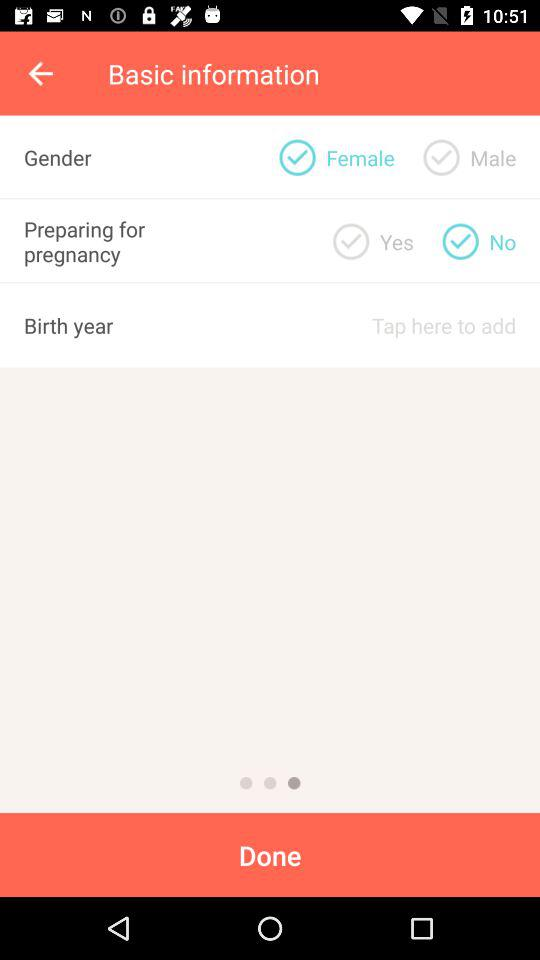What is the status of "Preparing for pregnancy"? The status is "No". 